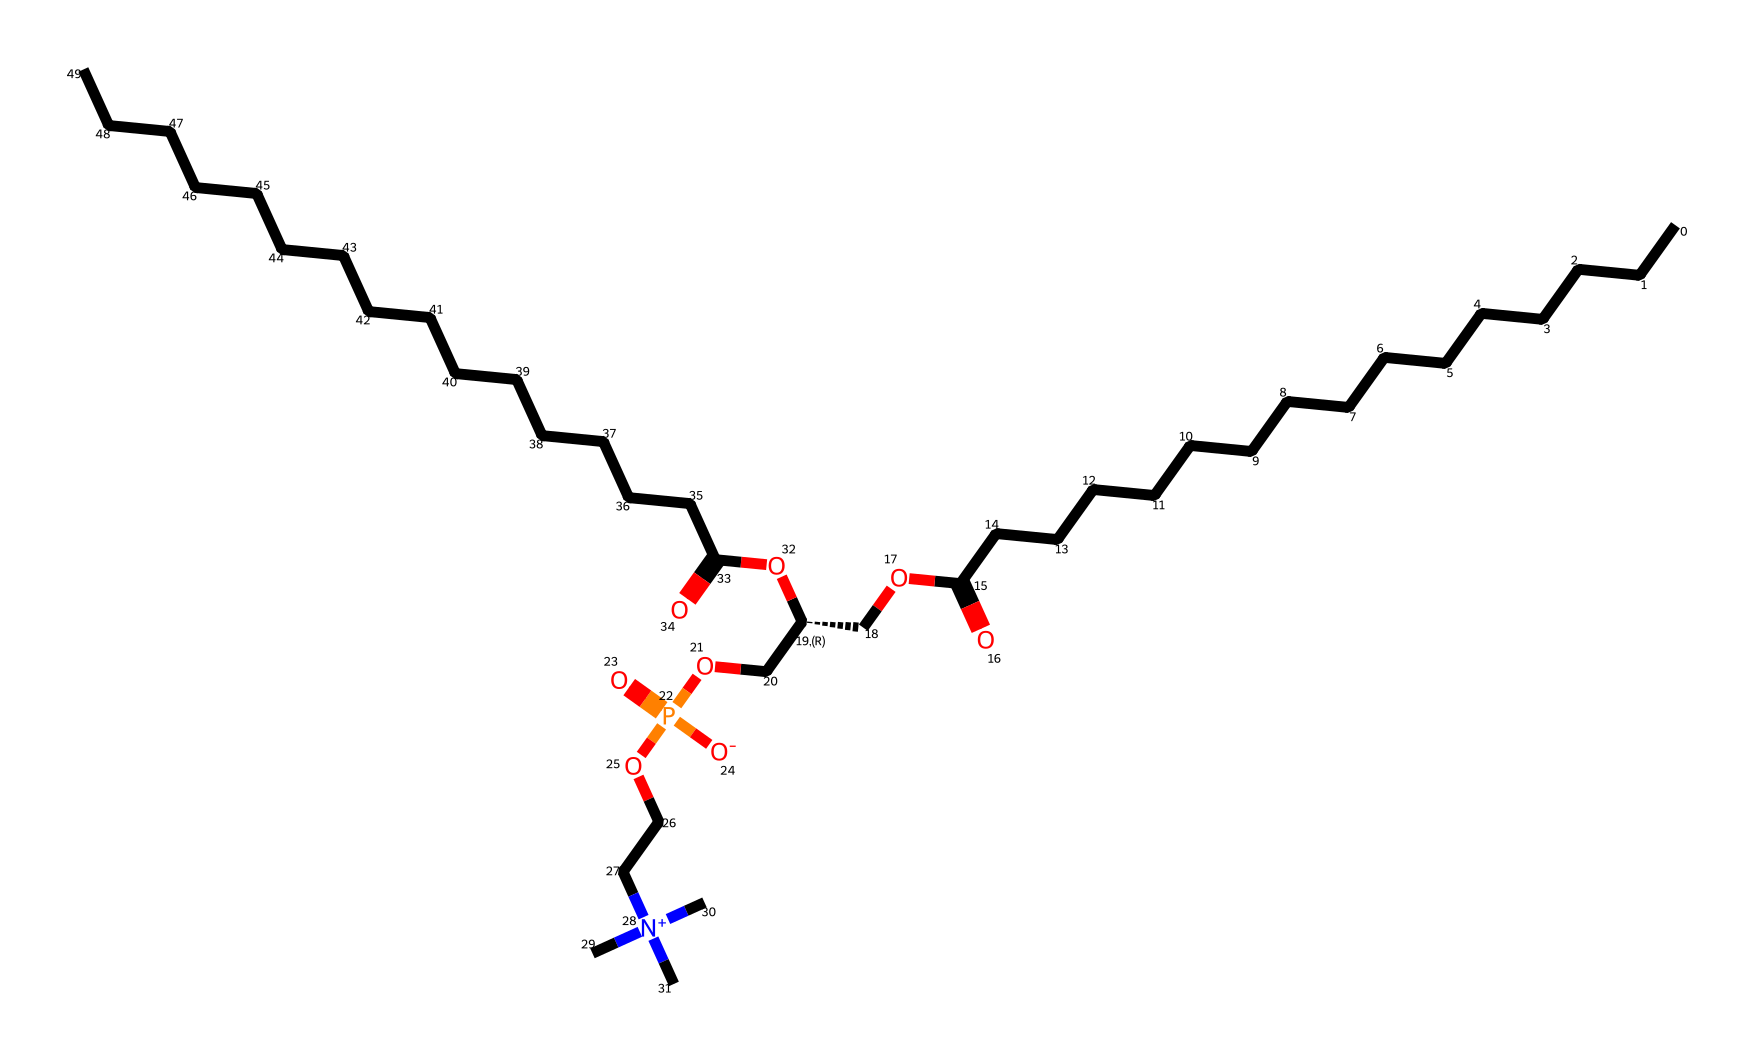What is the total number of carbon atoms in this phospholipid? By counting the number of 'C' in the SMILES representation, we find there are 24 carbon atoms in the structure.
Answer: 24 How many ester bonds are present in this molecule? The two ester groups are indicated by the "C(=O)O" pattern in the SMILES representation, which appears twice, indicating two ester bonds.
Answer: 2 What is the charge of the nitrogen in this structure? The nitrogen appears in a quaternary amine form, denoted as "[N+]", which indicates it has a positive charge.
Answer: positive What characteristic functional group indicates that this is a phospholipid? The presence of the phosphate group, indicated by the "P(=O)([O-])O" pattern in the SMILES, is characteristic of phospholipids.
Answer: phosphate Based on the structure, is this phospholipid saturated or unsaturated? The long carbon chains appear fully saturated as there are no double bonds indicated within the aliphatic chains.
Answer: saturated Which part of the molecule is hydrophilic? The phosphate group contains polar charges and contributes to a hydrophilic nature, while the fatty acid chains are hydrophobic.
Answer: phosphate group 